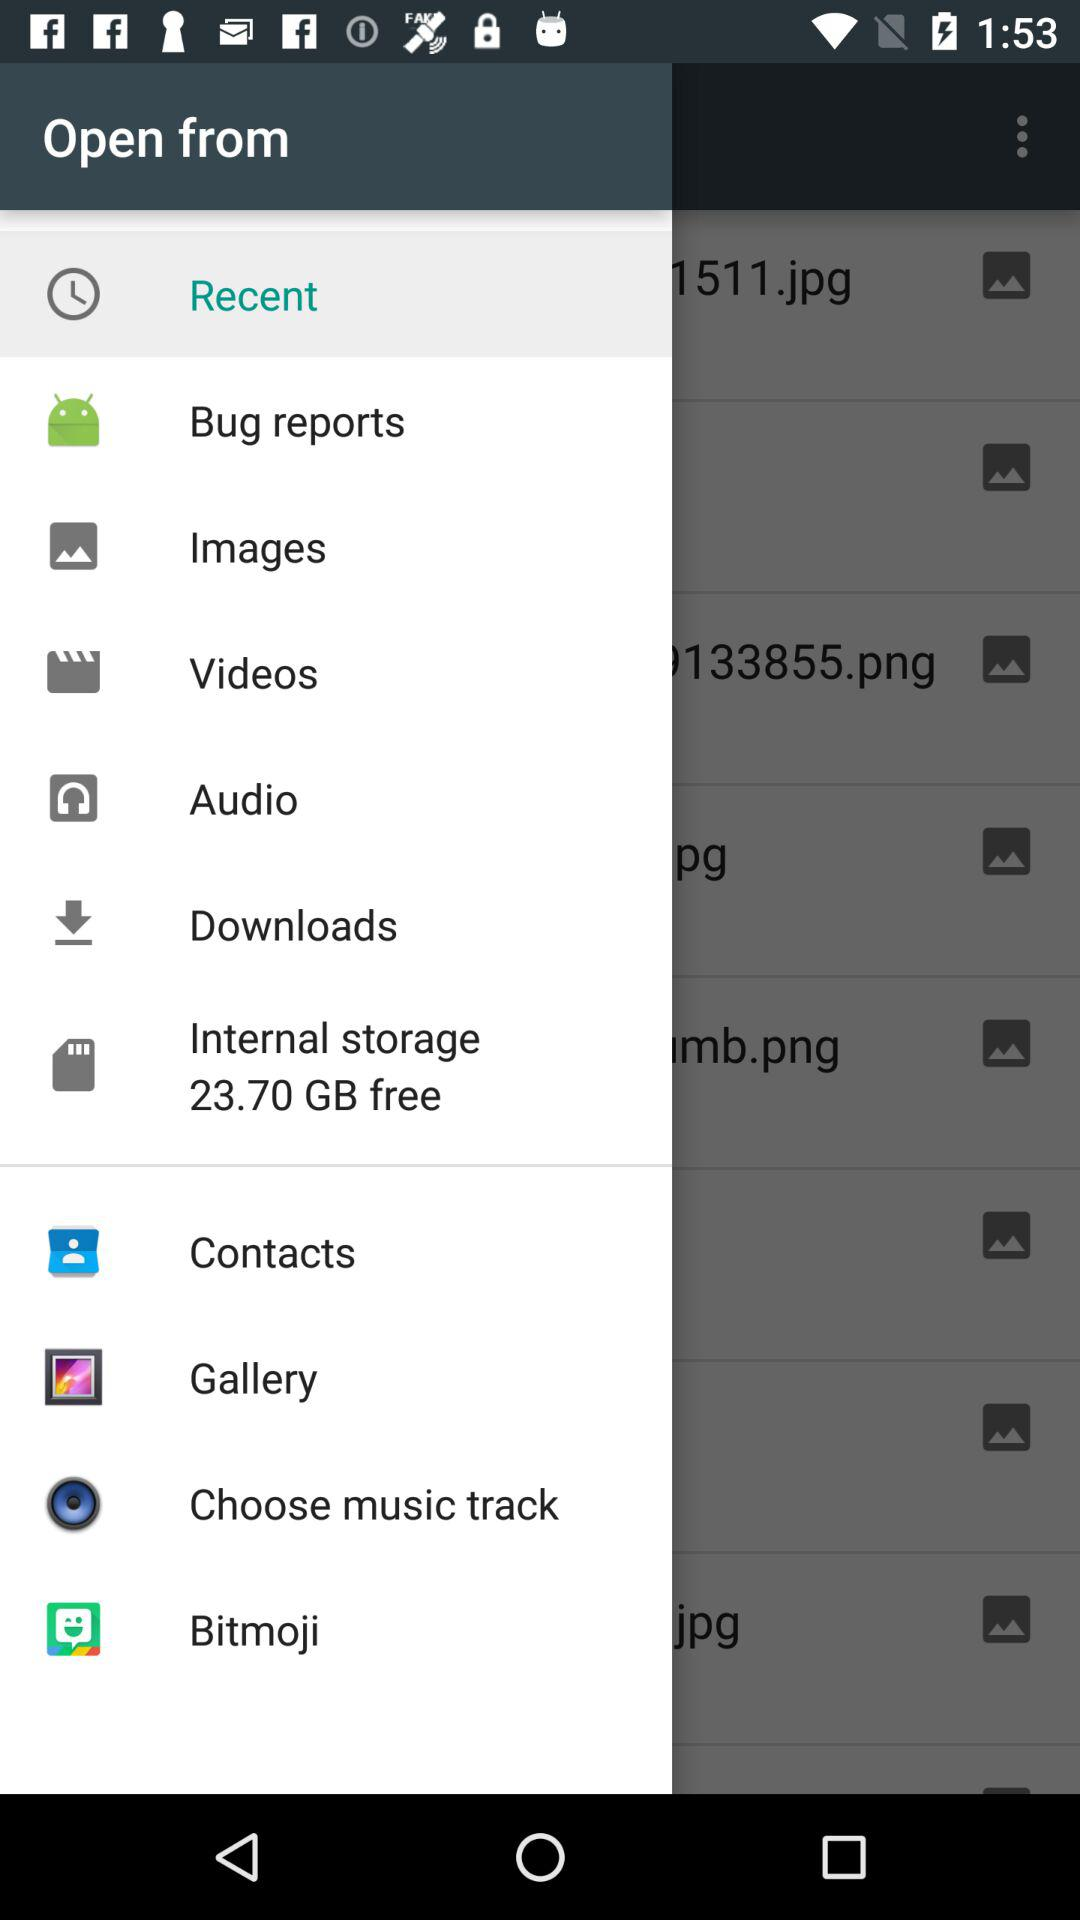What is the size of free internal storage? The size of free internal storage is 23.70 GB. 